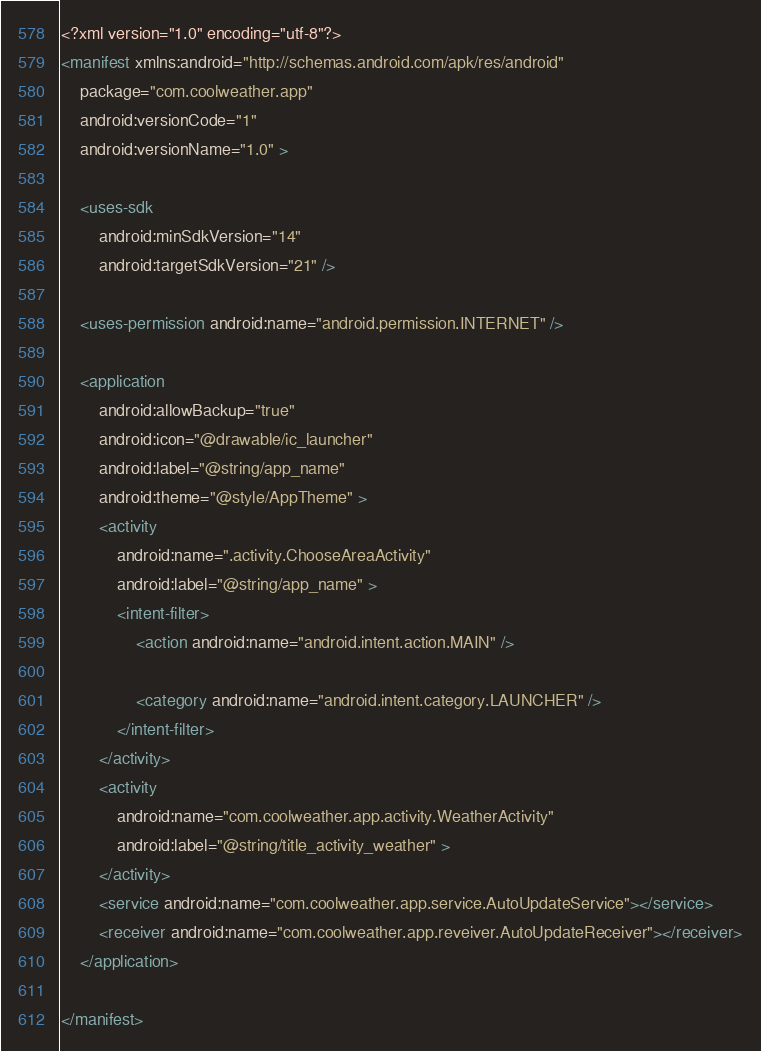<code> <loc_0><loc_0><loc_500><loc_500><_XML_><?xml version="1.0" encoding="utf-8"?>
<manifest xmlns:android="http://schemas.android.com/apk/res/android"
    package="com.coolweather.app"
    android:versionCode="1"
    android:versionName="1.0" >

    <uses-sdk
        android:minSdkVersion="14"
        android:targetSdkVersion="21" />

    <uses-permission android:name="android.permission.INTERNET" />

    <application
        android:allowBackup="true"
        android:icon="@drawable/ic_launcher"
        android:label="@string/app_name"
        android:theme="@style/AppTheme" >
        <activity
            android:name=".activity.ChooseAreaActivity"
            android:label="@string/app_name" >
            <intent-filter>
                <action android:name="android.intent.action.MAIN" />

                <category android:name="android.intent.category.LAUNCHER" />
            </intent-filter>
        </activity>
        <activity
            android:name="com.coolweather.app.activity.WeatherActivity"
            android:label="@string/title_activity_weather" >
        </activity>
        <service android:name="com.coolweather.app.service.AutoUpdateService"></service>
        <receiver android:name="com.coolweather.app.reveiver.AutoUpdateReceiver"></receiver>
    </application>

</manifest>
</code> 